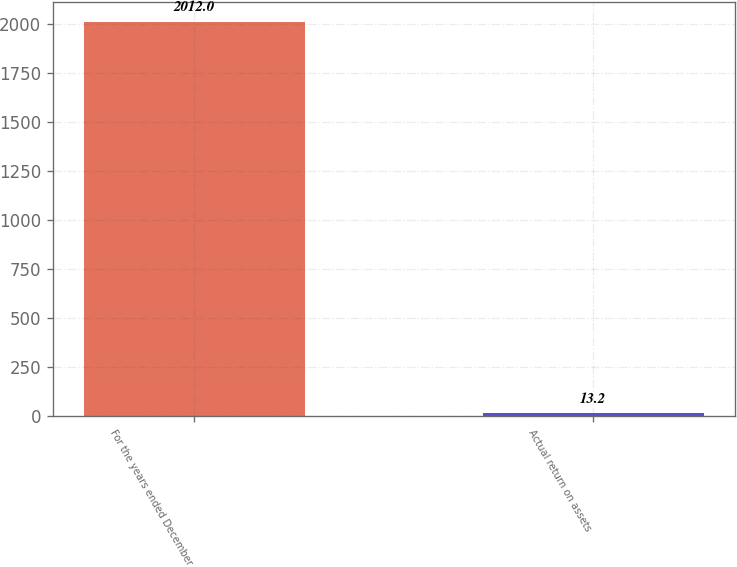Convert chart to OTSL. <chart><loc_0><loc_0><loc_500><loc_500><bar_chart><fcel>For the years ended December<fcel>Actual return on assets<nl><fcel>2012<fcel>13.2<nl></chart> 